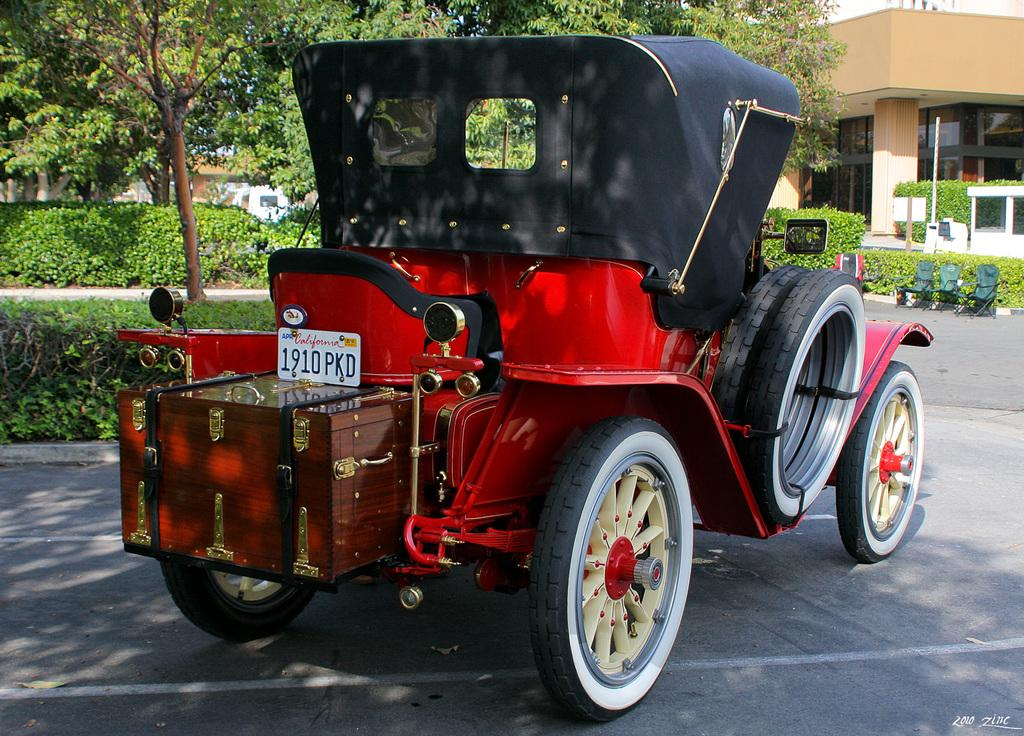What is the color of the vehicle on the road in the image? The vehicle on the road is red. What can be seen in the background of the image? There are trees and a building in the background of the image. What type of yak is your uncle riding in the image? There is no yak or uncle present in the image. What is your mind thinking about while looking at the image? The thoughts and feelings of the person looking at the image are not visible or present in the image itself. 